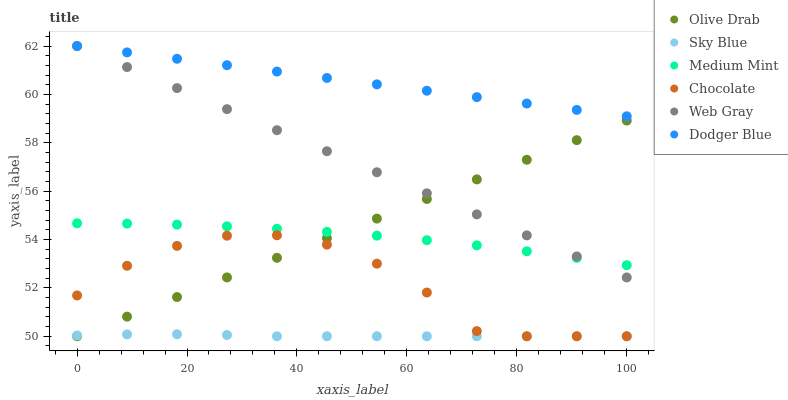Does Sky Blue have the minimum area under the curve?
Answer yes or no. Yes. Does Dodger Blue have the maximum area under the curve?
Answer yes or no. Yes. Does Web Gray have the minimum area under the curve?
Answer yes or no. No. Does Web Gray have the maximum area under the curve?
Answer yes or no. No. Is Dodger Blue the smoothest?
Answer yes or no. Yes. Is Chocolate the roughest?
Answer yes or no. Yes. Is Web Gray the smoothest?
Answer yes or no. No. Is Web Gray the roughest?
Answer yes or no. No. Does Chocolate have the lowest value?
Answer yes or no. Yes. Does Web Gray have the lowest value?
Answer yes or no. No. Does Dodger Blue have the highest value?
Answer yes or no. Yes. Does Chocolate have the highest value?
Answer yes or no. No. Is Olive Drab less than Dodger Blue?
Answer yes or no. Yes. Is Dodger Blue greater than Olive Drab?
Answer yes or no. Yes. Does Olive Drab intersect Sky Blue?
Answer yes or no. Yes. Is Olive Drab less than Sky Blue?
Answer yes or no. No. Is Olive Drab greater than Sky Blue?
Answer yes or no. No. Does Olive Drab intersect Dodger Blue?
Answer yes or no. No. 